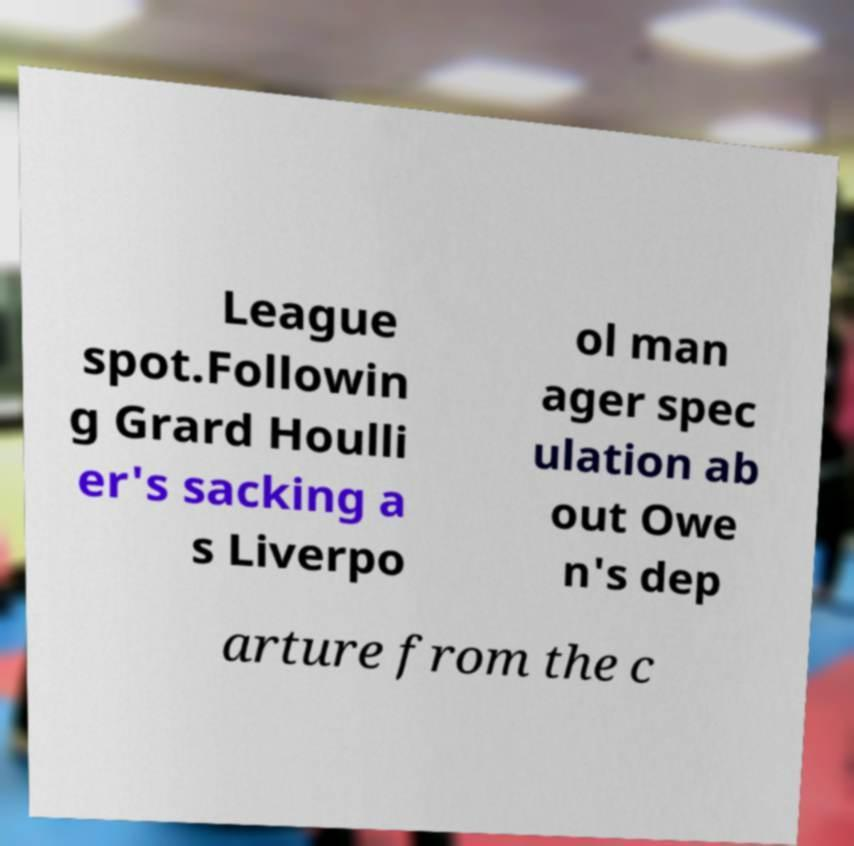Can you read and provide the text displayed in the image?This photo seems to have some interesting text. Can you extract and type it out for me? League spot.Followin g Grard Houlli er's sacking a s Liverpo ol man ager spec ulation ab out Owe n's dep arture from the c 